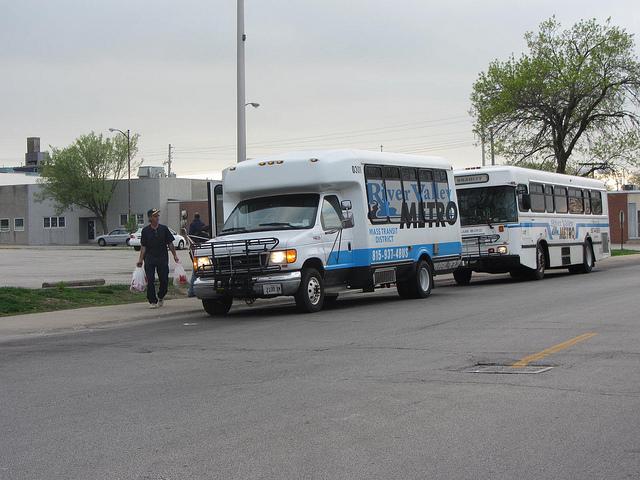What is at the closest end of the yellow line in the street?
Give a very brief answer. Manhole. How many buses are on this road?
Keep it brief. 2. What four letter word is on the side of the bus?
Answer briefly. Mass. How many buses are there?
Write a very short answer. 2. What color are the lines on the road?
Be succinct. Yellow. How many trucks are there?
Keep it brief. 2. Is this in the United States?
Short answer required. Yes. What's the number on the truck?
Short answer required. 8159374bus. Are the lights on the trucks?
Quick response, please. Yes. Is there a trash can?
Answer briefly. No. How many people can be seen?
Give a very brief answer. 2. Is there a designated place for pedestrians to cross?
Answer briefly. No. 